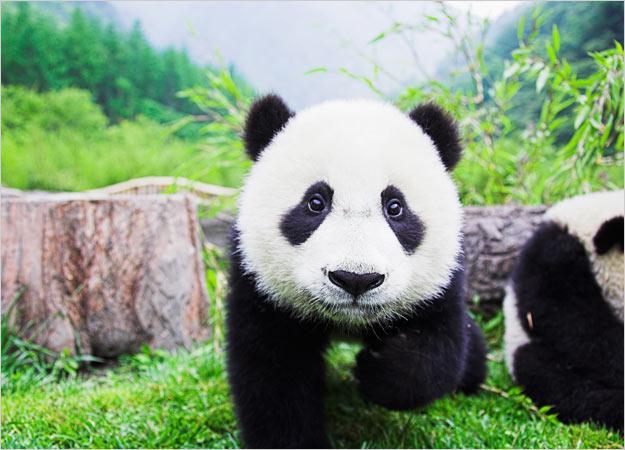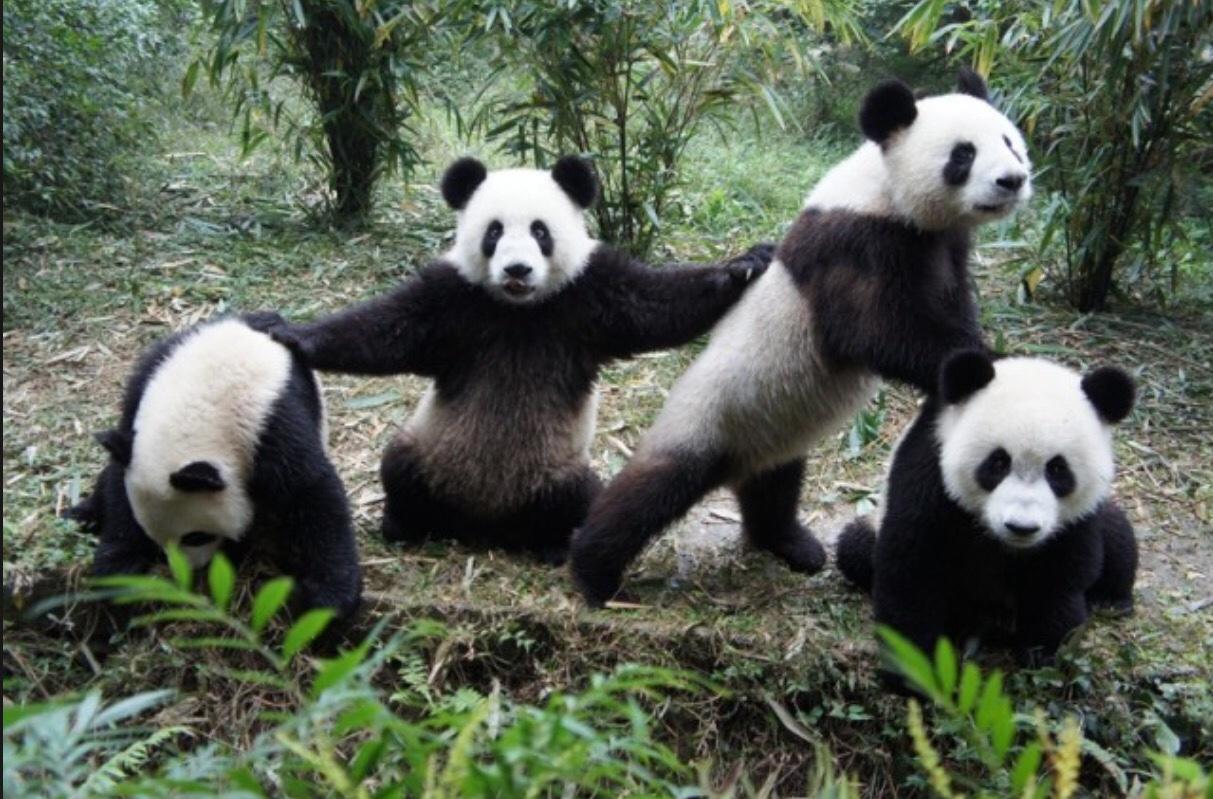The first image is the image on the left, the second image is the image on the right. Analyze the images presented: Is the assertion "At least one of the images has a big panda with a much smaller panda." valid? Answer yes or no. No. The first image is the image on the left, the second image is the image on the right. For the images displayed, is the sentence "One image has a baby panda being held while on top of an adult panda that is on its back." factually correct? Answer yes or no. No. 